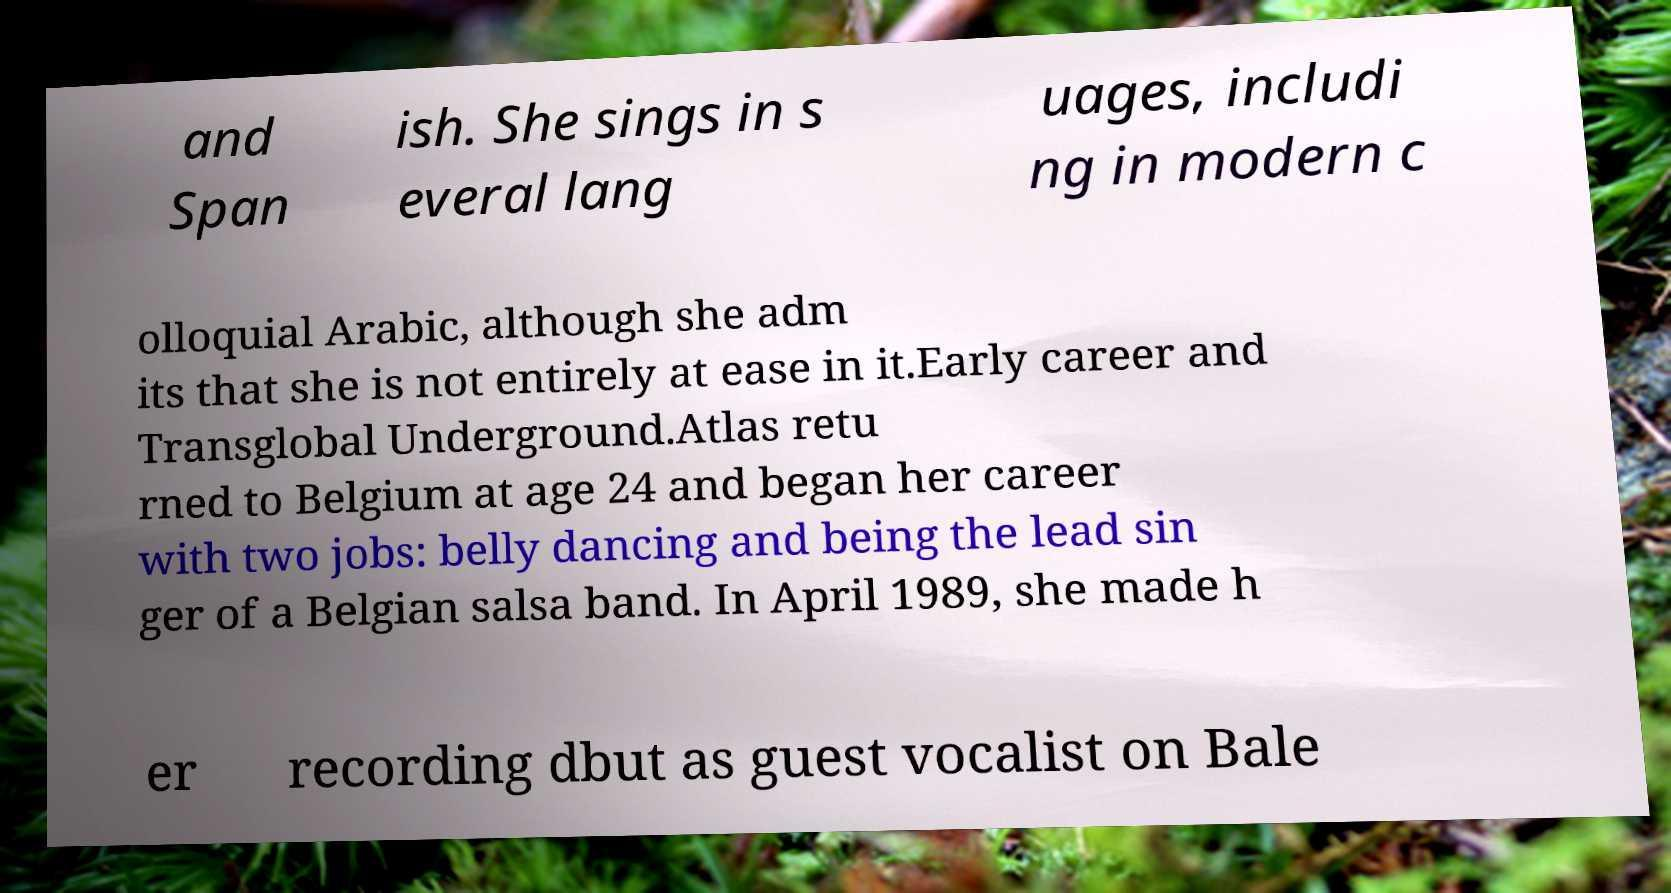Can you accurately transcribe the text from the provided image for me? and Span ish. She sings in s everal lang uages, includi ng in modern c olloquial Arabic, although she adm its that she is not entirely at ease in it.Early career and Transglobal Underground.Atlas retu rned to Belgium at age 24 and began her career with two jobs: belly dancing and being the lead sin ger of a Belgian salsa band. In April 1989, she made h er recording dbut as guest vocalist on Bale 